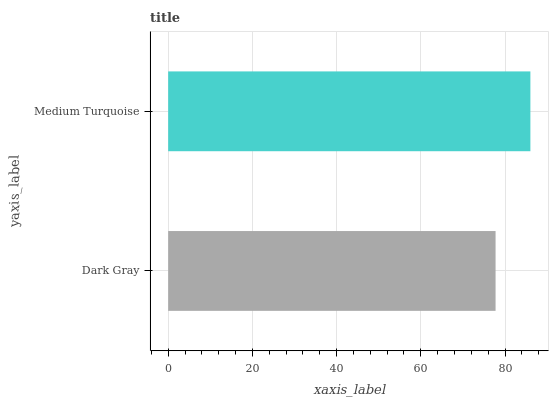Is Dark Gray the minimum?
Answer yes or no. Yes. Is Medium Turquoise the maximum?
Answer yes or no. Yes. Is Medium Turquoise the minimum?
Answer yes or no. No. Is Medium Turquoise greater than Dark Gray?
Answer yes or no. Yes. Is Dark Gray less than Medium Turquoise?
Answer yes or no. Yes. Is Dark Gray greater than Medium Turquoise?
Answer yes or no. No. Is Medium Turquoise less than Dark Gray?
Answer yes or no. No. Is Medium Turquoise the high median?
Answer yes or no. Yes. Is Dark Gray the low median?
Answer yes or no. Yes. Is Dark Gray the high median?
Answer yes or no. No. Is Medium Turquoise the low median?
Answer yes or no. No. 